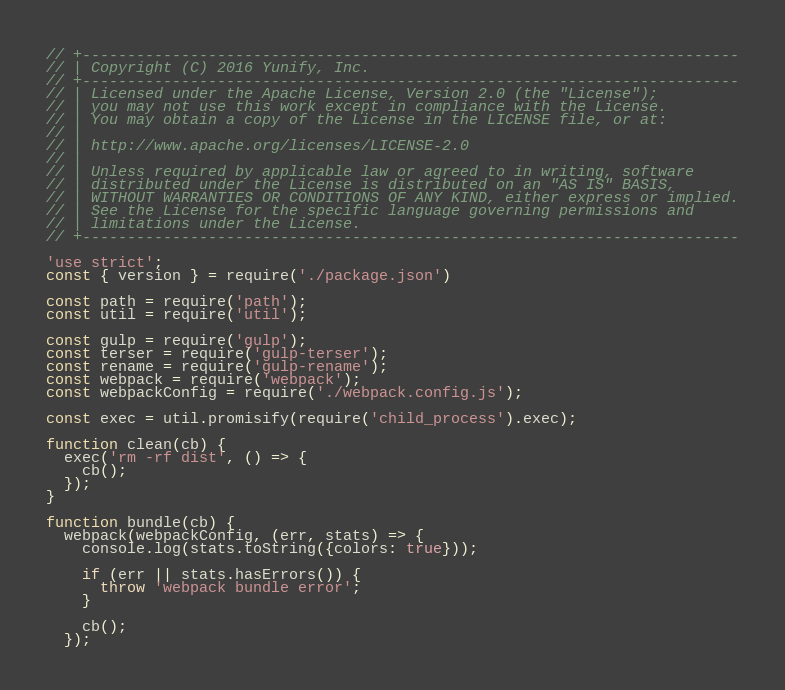<code> <loc_0><loc_0><loc_500><loc_500><_JavaScript_>// +-------------------------------------------------------------------------
// | Copyright (C) 2016 Yunify, Inc.
// +-------------------------------------------------------------------------
// | Licensed under the Apache License, Version 2.0 (the "License");
// | you may not use this work except in compliance with the License.
// | You may obtain a copy of the License in the LICENSE file, or at:
// |
// | http://www.apache.org/licenses/LICENSE-2.0
// |
// | Unless required by applicable law or agreed to in writing, software
// | distributed under the License is distributed on an "AS IS" BASIS,
// | WITHOUT WARRANTIES OR CONDITIONS OF ANY KIND, either express or implied.
// | See the License for the specific language governing permissions and
// | limitations under the License.
// +-------------------------------------------------------------------------

'use strict';
const { version } = require('./package.json')

const path = require('path');
const util = require('util');

const gulp = require('gulp');
const terser = require('gulp-terser');
const rename = require('gulp-rename');
const webpack = require('webpack');
const webpackConfig = require('./webpack.config.js');

const exec = util.promisify(require('child_process').exec);

function clean(cb) {
  exec('rm -rf dist', () => {
    cb();
  });
}

function bundle(cb) {
  webpack(webpackConfig, (err, stats) => {
    console.log(stats.toString({colors: true}));

    if (err || stats.hasErrors()) {
      throw 'webpack bundle error';
    }

    cb();
  });</code> 